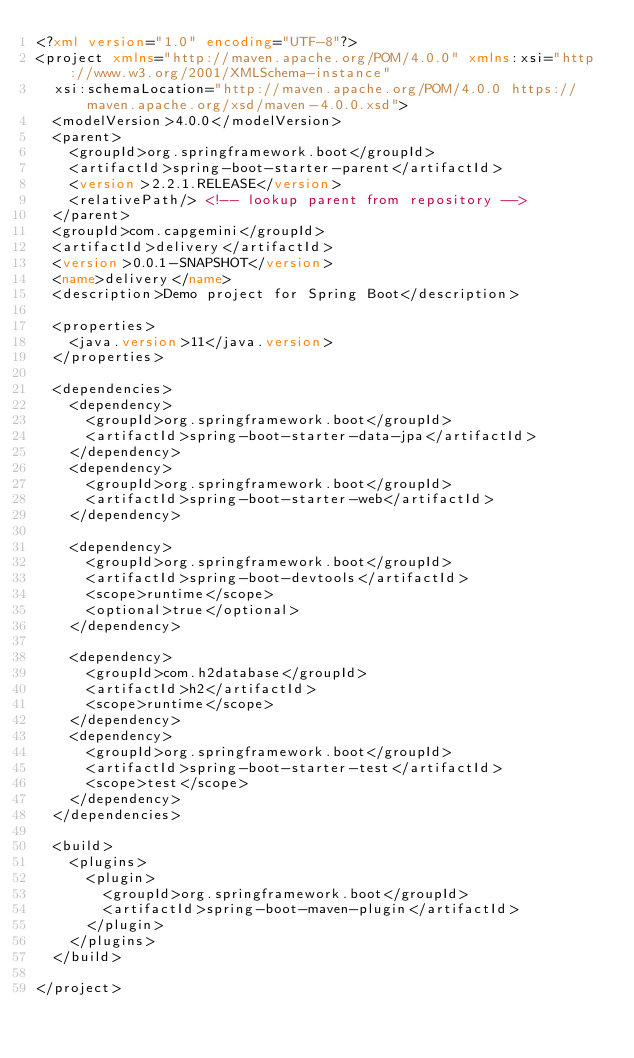<code> <loc_0><loc_0><loc_500><loc_500><_XML_><?xml version="1.0" encoding="UTF-8"?>
<project xmlns="http://maven.apache.org/POM/4.0.0" xmlns:xsi="http://www.w3.org/2001/XMLSchema-instance"
	xsi:schemaLocation="http://maven.apache.org/POM/4.0.0 https://maven.apache.org/xsd/maven-4.0.0.xsd">
	<modelVersion>4.0.0</modelVersion>
	<parent>
		<groupId>org.springframework.boot</groupId>
		<artifactId>spring-boot-starter-parent</artifactId>
		<version>2.2.1.RELEASE</version>
		<relativePath/> <!-- lookup parent from repository -->
	</parent>
	<groupId>com.capgemini</groupId>
	<artifactId>delivery</artifactId>
	<version>0.0.1-SNAPSHOT</version>
	<name>delivery</name>
	<description>Demo project for Spring Boot</description>

	<properties>
		<java.version>11</java.version>
	</properties>

	<dependencies>
		<dependency>
			<groupId>org.springframework.boot</groupId>
			<artifactId>spring-boot-starter-data-jpa</artifactId>
		</dependency>
		<dependency>
			<groupId>org.springframework.boot</groupId>
			<artifactId>spring-boot-starter-web</artifactId>
		</dependency>

		<dependency>
			<groupId>org.springframework.boot</groupId>
			<artifactId>spring-boot-devtools</artifactId>
			<scope>runtime</scope>
			<optional>true</optional>
		</dependency>
		
		<dependency>
			<groupId>com.h2database</groupId>
			<artifactId>h2</artifactId>
			<scope>runtime</scope>
		</dependency>
		<dependency>
			<groupId>org.springframework.boot</groupId>
			<artifactId>spring-boot-starter-test</artifactId>
			<scope>test</scope>
		</dependency>
	</dependencies>

	<build>
		<plugins>
			<plugin>
				<groupId>org.springframework.boot</groupId>
				<artifactId>spring-boot-maven-plugin</artifactId>
			</plugin>
		</plugins>
	</build>

</project>
</code> 